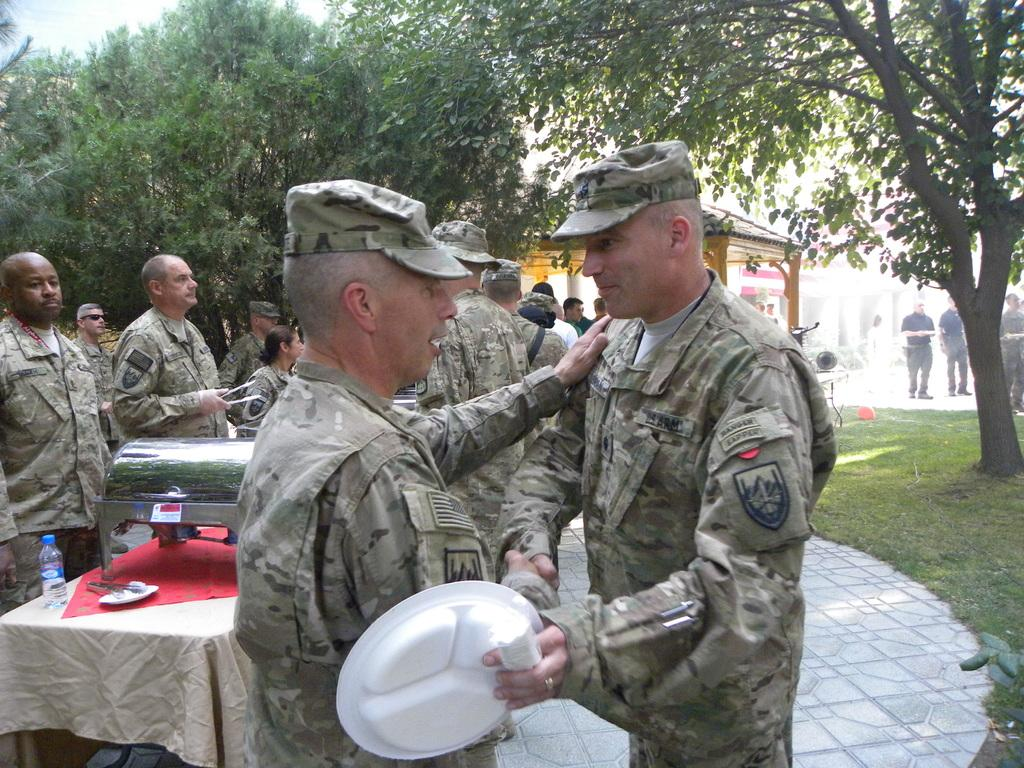How many people are in the foreground of the image? There are two people in the foreground of the image. What are the two people doing in the image? The two people are shaking hands with each other. What type of harbor can be seen in the image? There is no harbor present in the image. 